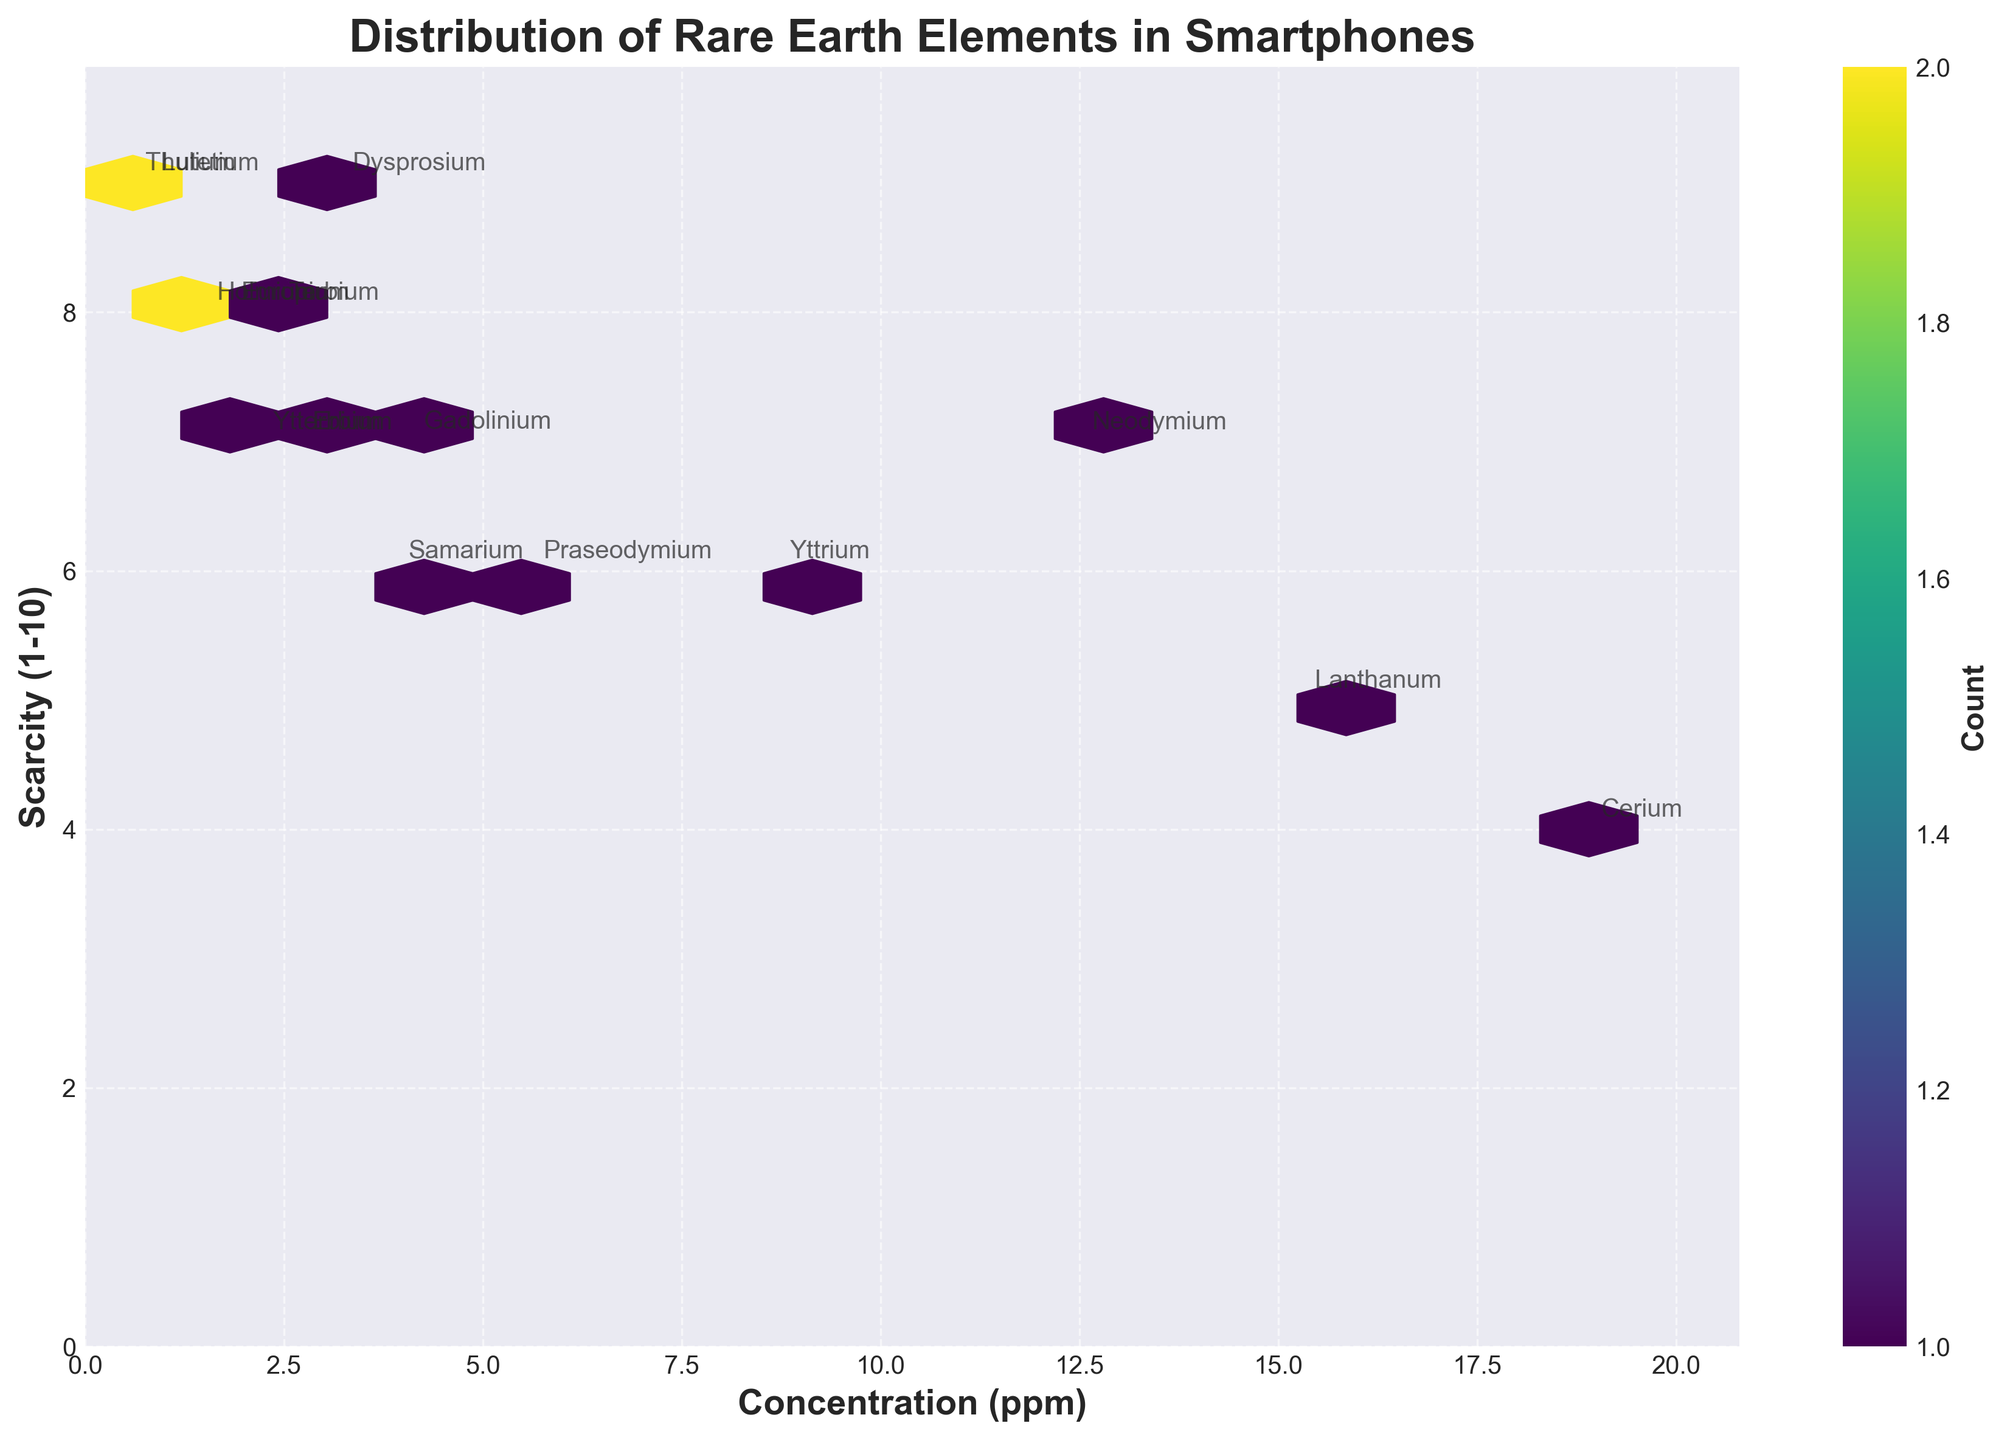What's the title of the figure? The title is found at the top of the figure and it summarizes what the plot is about.
Answer: Distribution of Rare Earth Elements in Smartphones Which element has the highest concentration (ppm)? By looking at the x-axis values and annotations, the element with the highest concentration is at the farthest right position on the x-axis.
Answer: Cerium What is the scarcity value of Yttrium? Find the annotation "Yttrium" and check its position on the y-axis to determine the scarcity value.
Answer: 6 How many elements have a scarcity value greater than or equal to 8? Identify hexagons positioned with y-values of 8 or higher and count the annotated elements within those hexagons.
Answer: 7 Which element has the lowest concentration (ppm) and what is its scarcity value? Locate the element annotation at the lowest x-axis value and check its corresponding y-axis position for scarcity.
Answer: Thulium, 9 Compare the concentration and scarcity values of Neodymium and Erbium. Which is more concentrated and which is scarcer? Find both elements' annotations and compare their x (concentration) and y (scarcity) values.
Answer: Neodymium is more concentrated; both have the same scarcity What's the median concentration (ppm) value of all elements? Order the concentration values: [0.6, 0.8, 1.5, 1.8, 2.2, 2.4, 2.7, 3.2, 3.9, 4.1, 5.6, 8.7, 12.5, 15.3, 18.9]; the middle value in the ordered list is the 8th value.
Answer: 3.9 Which element is the rarest considering both scarcity and low concentration? Identify the element with the highest scarcity value and among those select the one with the lowest concentration.
Answer: Thulium How is the scarcity of Cerium compared to its concentration? Find the annotation "Cerium" and observe its x (concentration) and y (scarcity) positions; compare the y value to the entire y-scale.
Answer: Cerium has high concentration and low scarcity What is the range of scarcity values seen in the figure? The range is determined by identifying the minimum and maximum values on the y-axis from the plotted data.
Answer: 5 (from 4 to 9) 